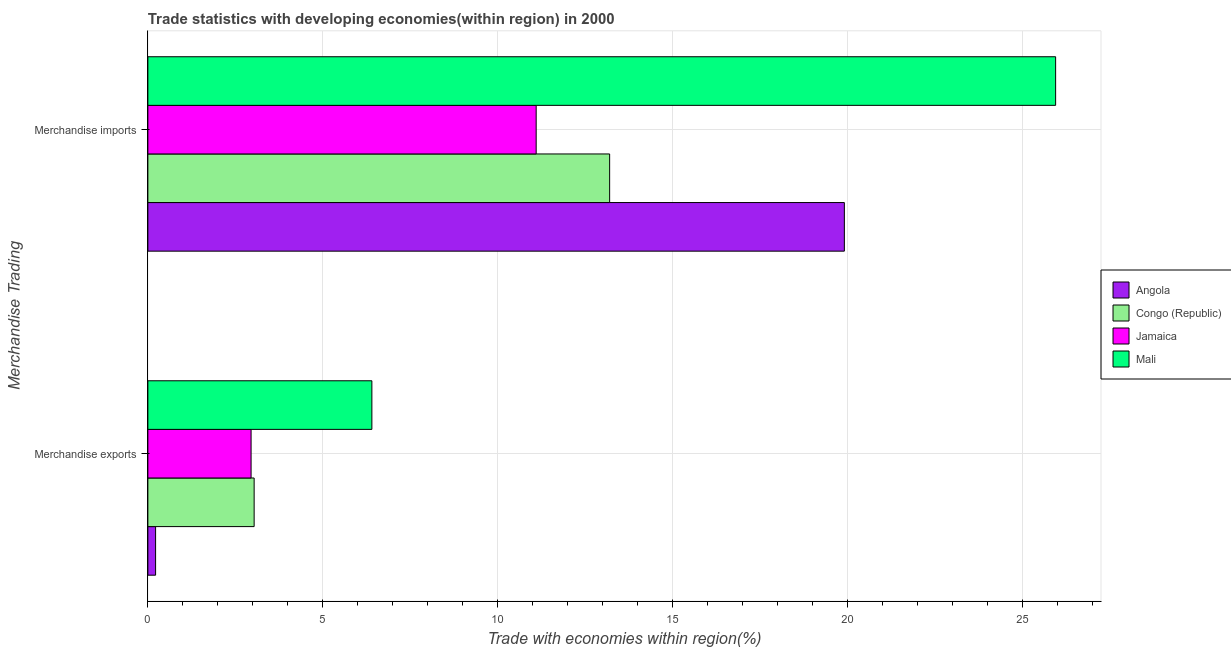Are the number of bars per tick equal to the number of legend labels?
Keep it short and to the point. Yes. Are the number of bars on each tick of the Y-axis equal?
Offer a very short reply. Yes. What is the merchandise imports in Congo (Republic)?
Your response must be concise. 13.21. Across all countries, what is the maximum merchandise imports?
Keep it short and to the point. 25.96. Across all countries, what is the minimum merchandise exports?
Keep it short and to the point. 0.22. In which country was the merchandise imports maximum?
Provide a short and direct response. Mali. In which country was the merchandise imports minimum?
Provide a short and direct response. Jamaica. What is the total merchandise exports in the graph?
Keep it short and to the point. 12.62. What is the difference between the merchandise exports in Angola and that in Mali?
Provide a short and direct response. -6.19. What is the difference between the merchandise imports in Angola and the merchandise exports in Mali?
Offer a very short reply. 13.51. What is the average merchandise exports per country?
Ensure brevity in your answer.  3.15. What is the difference between the merchandise exports and merchandise imports in Jamaica?
Keep it short and to the point. -8.15. In how many countries, is the merchandise imports greater than 9 %?
Your answer should be very brief. 4. What is the ratio of the merchandise exports in Jamaica to that in Mali?
Give a very brief answer. 0.46. What does the 3rd bar from the top in Merchandise exports represents?
Provide a succinct answer. Congo (Republic). What does the 3rd bar from the bottom in Merchandise exports represents?
Offer a very short reply. Jamaica. Are all the bars in the graph horizontal?
Provide a short and direct response. Yes. How many countries are there in the graph?
Offer a very short reply. 4. Are the values on the major ticks of X-axis written in scientific E-notation?
Make the answer very short. No. Does the graph contain grids?
Give a very brief answer. Yes. Where does the legend appear in the graph?
Keep it short and to the point. Center right. How many legend labels are there?
Your response must be concise. 4. How are the legend labels stacked?
Make the answer very short. Vertical. What is the title of the graph?
Make the answer very short. Trade statistics with developing economies(within region) in 2000. Does "Korea (Republic)" appear as one of the legend labels in the graph?
Your response must be concise. No. What is the label or title of the X-axis?
Offer a terse response. Trade with economies within region(%). What is the label or title of the Y-axis?
Keep it short and to the point. Merchandise Trading. What is the Trade with economies within region(%) in Angola in Merchandise exports?
Keep it short and to the point. 0.22. What is the Trade with economies within region(%) in Congo (Republic) in Merchandise exports?
Your response must be concise. 3.04. What is the Trade with economies within region(%) in Jamaica in Merchandise exports?
Provide a short and direct response. 2.95. What is the Trade with economies within region(%) of Mali in Merchandise exports?
Provide a short and direct response. 6.41. What is the Trade with economies within region(%) in Angola in Merchandise imports?
Give a very brief answer. 19.92. What is the Trade with economies within region(%) of Congo (Republic) in Merchandise imports?
Your answer should be compact. 13.21. What is the Trade with economies within region(%) in Jamaica in Merchandise imports?
Make the answer very short. 11.1. What is the Trade with economies within region(%) of Mali in Merchandise imports?
Give a very brief answer. 25.96. Across all Merchandise Trading, what is the maximum Trade with economies within region(%) in Angola?
Your answer should be very brief. 19.92. Across all Merchandise Trading, what is the maximum Trade with economies within region(%) in Congo (Republic)?
Ensure brevity in your answer.  13.21. Across all Merchandise Trading, what is the maximum Trade with economies within region(%) in Jamaica?
Your answer should be compact. 11.1. Across all Merchandise Trading, what is the maximum Trade with economies within region(%) of Mali?
Keep it short and to the point. 25.96. Across all Merchandise Trading, what is the minimum Trade with economies within region(%) of Angola?
Your response must be concise. 0.22. Across all Merchandise Trading, what is the minimum Trade with economies within region(%) of Congo (Republic)?
Your response must be concise. 3.04. Across all Merchandise Trading, what is the minimum Trade with economies within region(%) of Jamaica?
Make the answer very short. 2.95. Across all Merchandise Trading, what is the minimum Trade with economies within region(%) of Mali?
Make the answer very short. 6.41. What is the total Trade with economies within region(%) of Angola in the graph?
Provide a short and direct response. 20.14. What is the total Trade with economies within region(%) of Congo (Republic) in the graph?
Make the answer very short. 16.25. What is the total Trade with economies within region(%) in Jamaica in the graph?
Give a very brief answer. 14.06. What is the total Trade with economies within region(%) of Mali in the graph?
Provide a succinct answer. 32.37. What is the difference between the Trade with economies within region(%) of Angola in Merchandise exports and that in Merchandise imports?
Offer a very short reply. -19.7. What is the difference between the Trade with economies within region(%) in Congo (Republic) in Merchandise exports and that in Merchandise imports?
Your answer should be compact. -10.17. What is the difference between the Trade with economies within region(%) of Jamaica in Merchandise exports and that in Merchandise imports?
Provide a short and direct response. -8.15. What is the difference between the Trade with economies within region(%) in Mali in Merchandise exports and that in Merchandise imports?
Your answer should be very brief. -19.55. What is the difference between the Trade with economies within region(%) of Angola in Merchandise exports and the Trade with economies within region(%) of Congo (Republic) in Merchandise imports?
Give a very brief answer. -12.99. What is the difference between the Trade with economies within region(%) of Angola in Merchandise exports and the Trade with economies within region(%) of Jamaica in Merchandise imports?
Provide a short and direct response. -10.88. What is the difference between the Trade with economies within region(%) of Angola in Merchandise exports and the Trade with economies within region(%) of Mali in Merchandise imports?
Keep it short and to the point. -25.74. What is the difference between the Trade with economies within region(%) of Congo (Republic) in Merchandise exports and the Trade with economies within region(%) of Jamaica in Merchandise imports?
Ensure brevity in your answer.  -8.07. What is the difference between the Trade with economies within region(%) in Congo (Republic) in Merchandise exports and the Trade with economies within region(%) in Mali in Merchandise imports?
Your response must be concise. -22.92. What is the difference between the Trade with economies within region(%) of Jamaica in Merchandise exports and the Trade with economies within region(%) of Mali in Merchandise imports?
Offer a terse response. -23.01. What is the average Trade with economies within region(%) of Angola per Merchandise Trading?
Ensure brevity in your answer.  10.07. What is the average Trade with economies within region(%) of Congo (Republic) per Merchandise Trading?
Keep it short and to the point. 8.12. What is the average Trade with economies within region(%) in Jamaica per Merchandise Trading?
Provide a succinct answer. 7.03. What is the average Trade with economies within region(%) in Mali per Merchandise Trading?
Offer a very short reply. 16.18. What is the difference between the Trade with economies within region(%) of Angola and Trade with economies within region(%) of Congo (Republic) in Merchandise exports?
Your answer should be very brief. -2.82. What is the difference between the Trade with economies within region(%) of Angola and Trade with economies within region(%) of Jamaica in Merchandise exports?
Your response must be concise. -2.73. What is the difference between the Trade with economies within region(%) in Angola and Trade with economies within region(%) in Mali in Merchandise exports?
Your response must be concise. -6.19. What is the difference between the Trade with economies within region(%) in Congo (Republic) and Trade with economies within region(%) in Jamaica in Merchandise exports?
Ensure brevity in your answer.  0.09. What is the difference between the Trade with economies within region(%) of Congo (Republic) and Trade with economies within region(%) of Mali in Merchandise exports?
Give a very brief answer. -3.37. What is the difference between the Trade with economies within region(%) in Jamaica and Trade with economies within region(%) in Mali in Merchandise exports?
Your answer should be very brief. -3.45. What is the difference between the Trade with economies within region(%) in Angola and Trade with economies within region(%) in Congo (Republic) in Merchandise imports?
Offer a terse response. 6.71. What is the difference between the Trade with economies within region(%) of Angola and Trade with economies within region(%) of Jamaica in Merchandise imports?
Offer a very short reply. 8.81. What is the difference between the Trade with economies within region(%) in Angola and Trade with economies within region(%) in Mali in Merchandise imports?
Make the answer very short. -6.04. What is the difference between the Trade with economies within region(%) in Congo (Republic) and Trade with economies within region(%) in Jamaica in Merchandise imports?
Make the answer very short. 2.1. What is the difference between the Trade with economies within region(%) of Congo (Republic) and Trade with economies within region(%) of Mali in Merchandise imports?
Ensure brevity in your answer.  -12.75. What is the difference between the Trade with economies within region(%) of Jamaica and Trade with economies within region(%) of Mali in Merchandise imports?
Offer a terse response. -14.86. What is the ratio of the Trade with economies within region(%) of Angola in Merchandise exports to that in Merchandise imports?
Your answer should be very brief. 0.01. What is the ratio of the Trade with economies within region(%) in Congo (Republic) in Merchandise exports to that in Merchandise imports?
Offer a very short reply. 0.23. What is the ratio of the Trade with economies within region(%) in Jamaica in Merchandise exports to that in Merchandise imports?
Make the answer very short. 0.27. What is the ratio of the Trade with economies within region(%) in Mali in Merchandise exports to that in Merchandise imports?
Give a very brief answer. 0.25. What is the difference between the highest and the second highest Trade with economies within region(%) of Angola?
Your response must be concise. 19.7. What is the difference between the highest and the second highest Trade with economies within region(%) of Congo (Republic)?
Provide a succinct answer. 10.17. What is the difference between the highest and the second highest Trade with economies within region(%) of Jamaica?
Make the answer very short. 8.15. What is the difference between the highest and the second highest Trade with economies within region(%) of Mali?
Offer a terse response. 19.55. What is the difference between the highest and the lowest Trade with economies within region(%) in Angola?
Offer a terse response. 19.7. What is the difference between the highest and the lowest Trade with economies within region(%) of Congo (Republic)?
Keep it short and to the point. 10.17. What is the difference between the highest and the lowest Trade with economies within region(%) of Jamaica?
Ensure brevity in your answer.  8.15. What is the difference between the highest and the lowest Trade with economies within region(%) in Mali?
Provide a succinct answer. 19.55. 